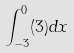Convert formula to latex. <formula><loc_0><loc_0><loc_500><loc_500>\int _ { - 3 } ^ { 0 } ( 3 ) d x</formula> 